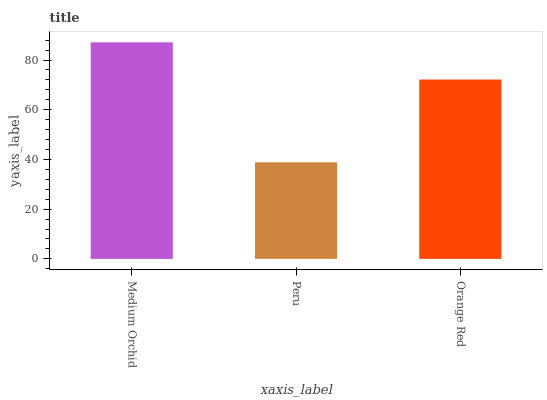Is Peru the minimum?
Answer yes or no. Yes. Is Medium Orchid the maximum?
Answer yes or no. Yes. Is Orange Red the minimum?
Answer yes or no. No. Is Orange Red the maximum?
Answer yes or no. No. Is Orange Red greater than Peru?
Answer yes or no. Yes. Is Peru less than Orange Red?
Answer yes or no. Yes. Is Peru greater than Orange Red?
Answer yes or no. No. Is Orange Red less than Peru?
Answer yes or no. No. Is Orange Red the high median?
Answer yes or no. Yes. Is Orange Red the low median?
Answer yes or no. Yes. Is Peru the high median?
Answer yes or no. No. Is Peru the low median?
Answer yes or no. No. 